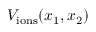Convert formula to latex. <formula><loc_0><loc_0><loc_500><loc_500>V _ { i o n s } ( x _ { 1 } , x _ { 2 } )</formula> 